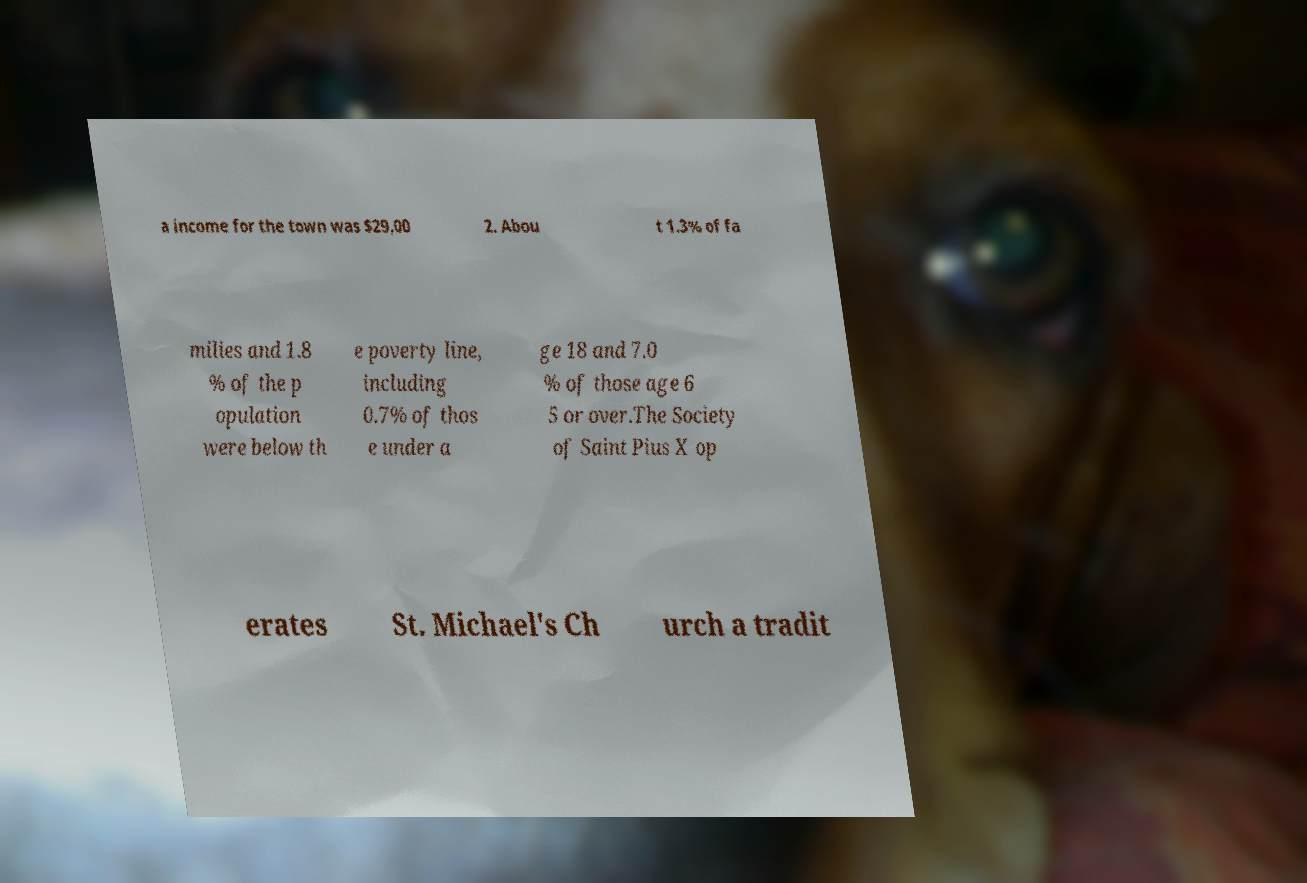What messages or text are displayed in this image? I need them in a readable, typed format. a income for the town was $29,00 2. Abou t 1.3% of fa milies and 1.8 % of the p opulation were below th e poverty line, including 0.7% of thos e under a ge 18 and 7.0 % of those age 6 5 or over.The Society of Saint Pius X op erates St. Michael's Ch urch a tradit 